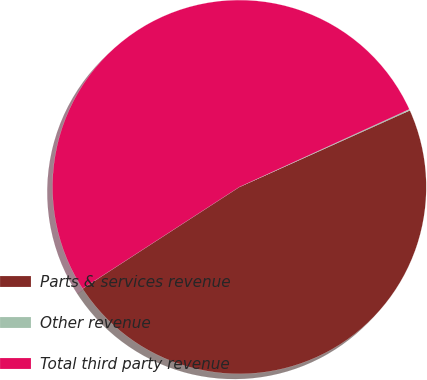Convert chart. <chart><loc_0><loc_0><loc_500><loc_500><pie_chart><fcel>Parts & services revenue<fcel>Other revenue<fcel>Total third party revenue<nl><fcel>47.57%<fcel>0.1%<fcel>52.33%<nl></chart> 